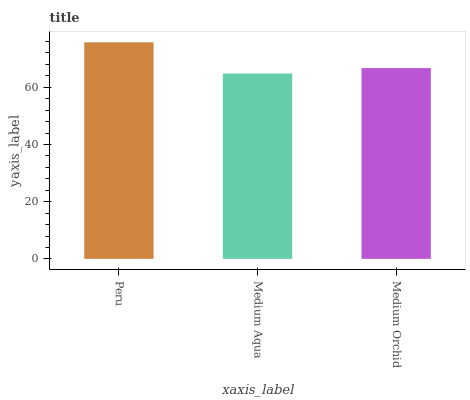Is Medium Aqua the minimum?
Answer yes or no. Yes. Is Peru the maximum?
Answer yes or no. Yes. Is Medium Orchid the minimum?
Answer yes or no. No. Is Medium Orchid the maximum?
Answer yes or no. No. Is Medium Orchid greater than Medium Aqua?
Answer yes or no. Yes. Is Medium Aqua less than Medium Orchid?
Answer yes or no. Yes. Is Medium Aqua greater than Medium Orchid?
Answer yes or no. No. Is Medium Orchid less than Medium Aqua?
Answer yes or no. No. Is Medium Orchid the high median?
Answer yes or no. Yes. Is Medium Orchid the low median?
Answer yes or no. Yes. Is Peru the high median?
Answer yes or no. No. Is Peru the low median?
Answer yes or no. No. 